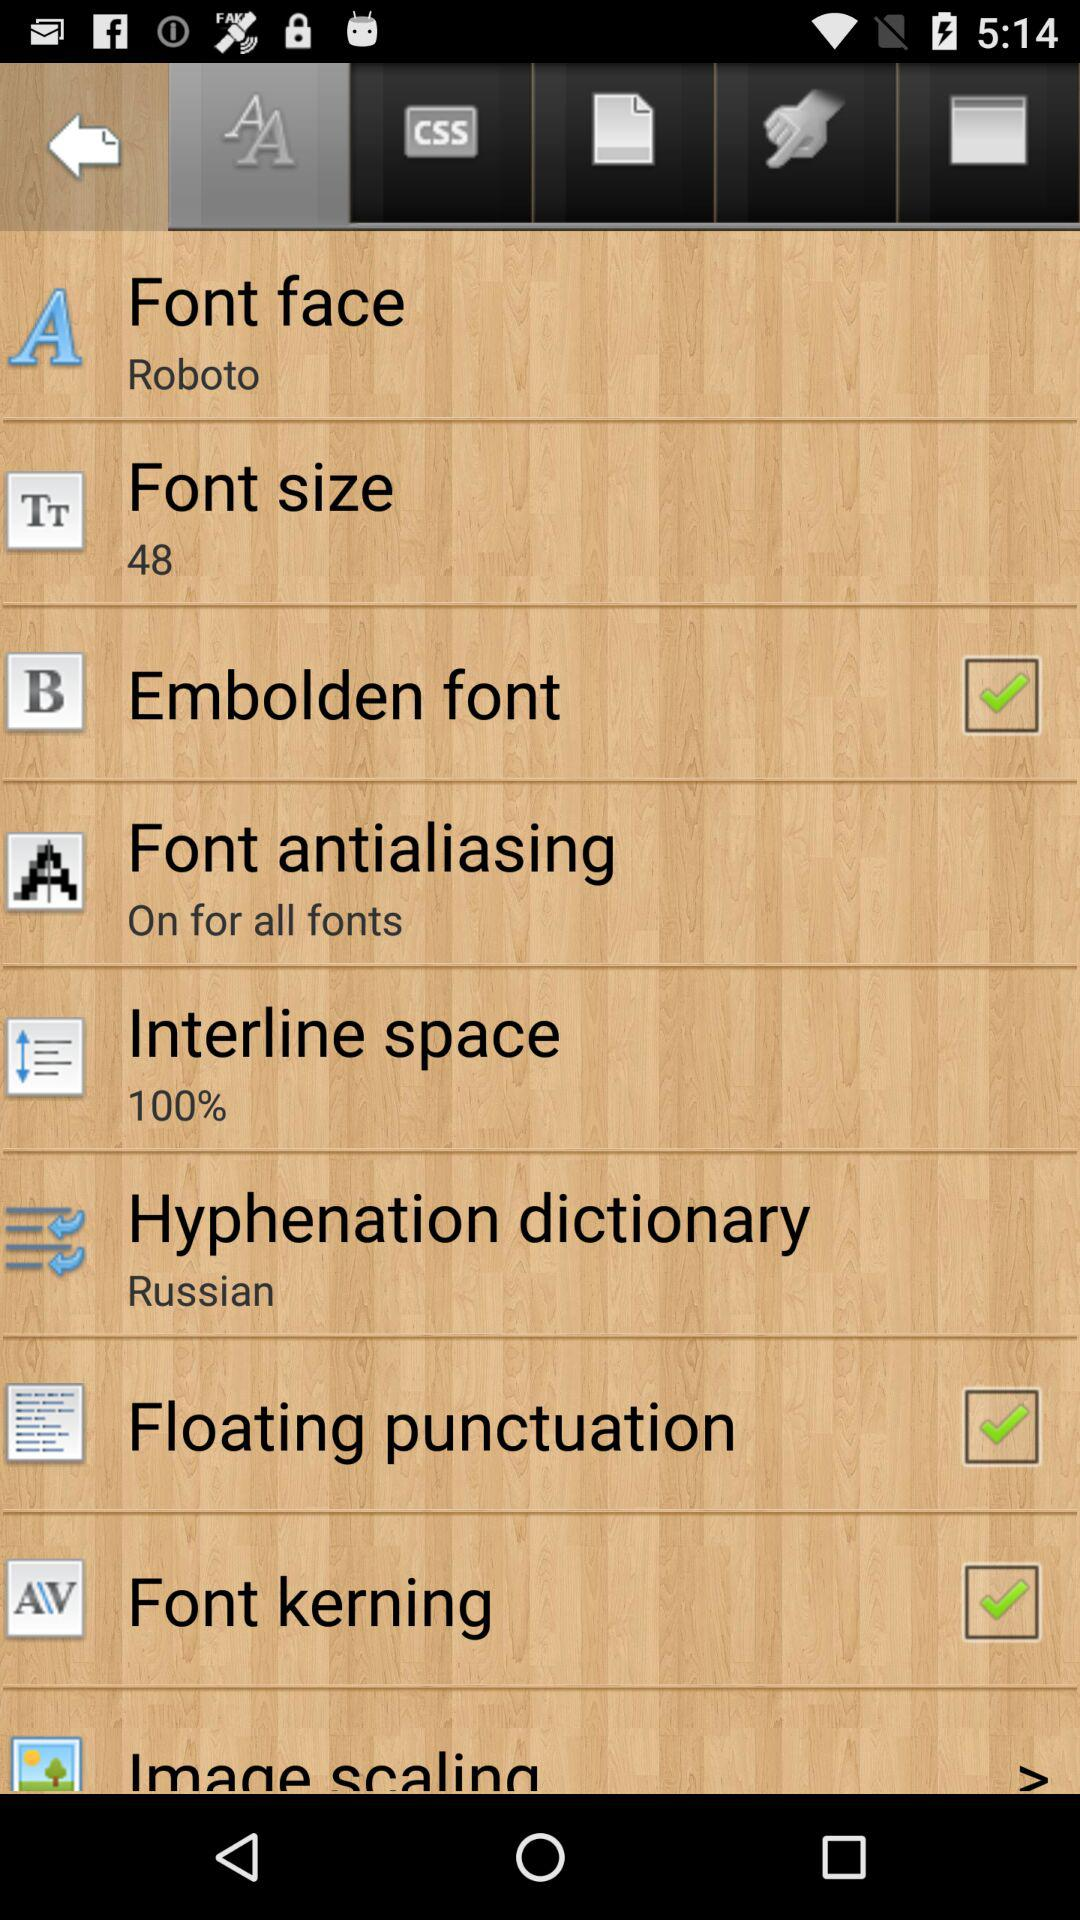What percentage of interline space is selected? The selected percentage of interline space is 100. 